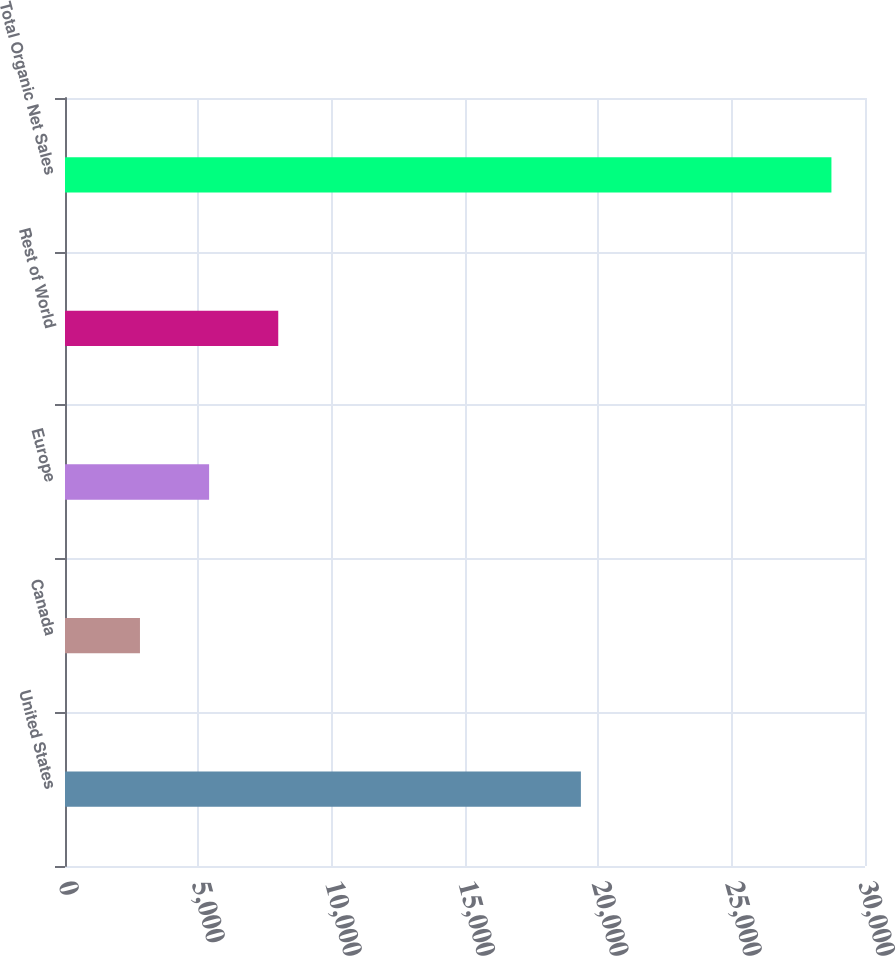<chart> <loc_0><loc_0><loc_500><loc_500><bar_chart><fcel>United States<fcel>Canada<fcel>Europe<fcel>Rest of World<fcel>Total Organic Net Sales<nl><fcel>19346<fcel>2811<fcel>5404<fcel>7997<fcel>28741<nl></chart> 